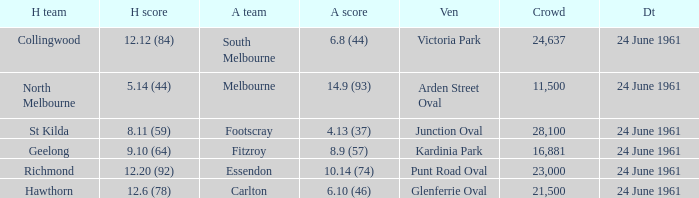What was the average crowd size of games held at Glenferrie Oval? 21500.0. 